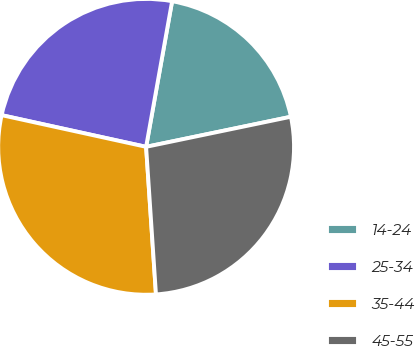Convert chart. <chart><loc_0><loc_0><loc_500><loc_500><pie_chart><fcel>14-24<fcel>25-34<fcel>35-44<fcel>45-55<nl><fcel>18.93%<fcel>24.38%<fcel>29.5%<fcel>27.2%<nl></chart> 